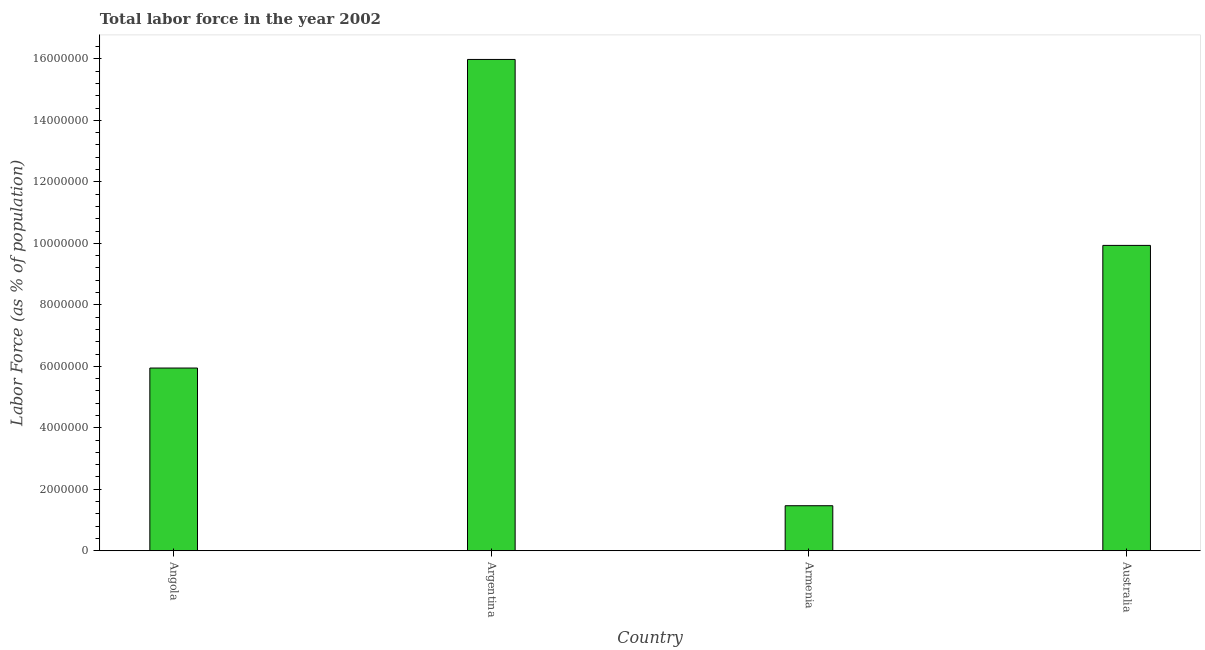Does the graph contain grids?
Make the answer very short. No. What is the title of the graph?
Your answer should be compact. Total labor force in the year 2002. What is the label or title of the Y-axis?
Make the answer very short. Labor Force (as % of population). What is the total labor force in Angola?
Make the answer very short. 5.94e+06. Across all countries, what is the maximum total labor force?
Provide a succinct answer. 1.60e+07. Across all countries, what is the minimum total labor force?
Provide a short and direct response. 1.47e+06. In which country was the total labor force maximum?
Your response must be concise. Argentina. In which country was the total labor force minimum?
Your answer should be compact. Armenia. What is the sum of the total labor force?
Make the answer very short. 3.33e+07. What is the difference between the total labor force in Argentina and Australia?
Your response must be concise. 6.05e+06. What is the average total labor force per country?
Ensure brevity in your answer.  8.33e+06. What is the median total labor force?
Provide a succinct answer. 7.94e+06. What is the ratio of the total labor force in Angola to that in Argentina?
Your answer should be compact. 0.37. What is the difference between the highest and the second highest total labor force?
Your response must be concise. 6.05e+06. What is the difference between the highest and the lowest total labor force?
Your answer should be very brief. 1.45e+07. Are all the bars in the graph horizontal?
Offer a terse response. No. What is the difference between two consecutive major ticks on the Y-axis?
Offer a terse response. 2.00e+06. Are the values on the major ticks of Y-axis written in scientific E-notation?
Keep it short and to the point. No. What is the Labor Force (as % of population) in Angola?
Make the answer very short. 5.94e+06. What is the Labor Force (as % of population) in Argentina?
Your answer should be very brief. 1.60e+07. What is the Labor Force (as % of population) of Armenia?
Ensure brevity in your answer.  1.47e+06. What is the Labor Force (as % of population) in Australia?
Provide a short and direct response. 9.93e+06. What is the difference between the Labor Force (as % of population) in Angola and Argentina?
Ensure brevity in your answer.  -1.00e+07. What is the difference between the Labor Force (as % of population) in Angola and Armenia?
Keep it short and to the point. 4.48e+06. What is the difference between the Labor Force (as % of population) in Angola and Australia?
Your answer should be compact. -3.99e+06. What is the difference between the Labor Force (as % of population) in Argentina and Armenia?
Offer a terse response. 1.45e+07. What is the difference between the Labor Force (as % of population) in Argentina and Australia?
Ensure brevity in your answer.  6.05e+06. What is the difference between the Labor Force (as % of population) in Armenia and Australia?
Offer a terse response. -8.47e+06. What is the ratio of the Labor Force (as % of population) in Angola to that in Argentina?
Offer a terse response. 0.37. What is the ratio of the Labor Force (as % of population) in Angola to that in Armenia?
Offer a terse response. 4.06. What is the ratio of the Labor Force (as % of population) in Angola to that in Australia?
Offer a terse response. 0.6. What is the ratio of the Labor Force (as % of population) in Argentina to that in Armenia?
Provide a succinct answer. 10.9. What is the ratio of the Labor Force (as % of population) in Argentina to that in Australia?
Your answer should be very brief. 1.61. What is the ratio of the Labor Force (as % of population) in Armenia to that in Australia?
Provide a succinct answer. 0.15. 